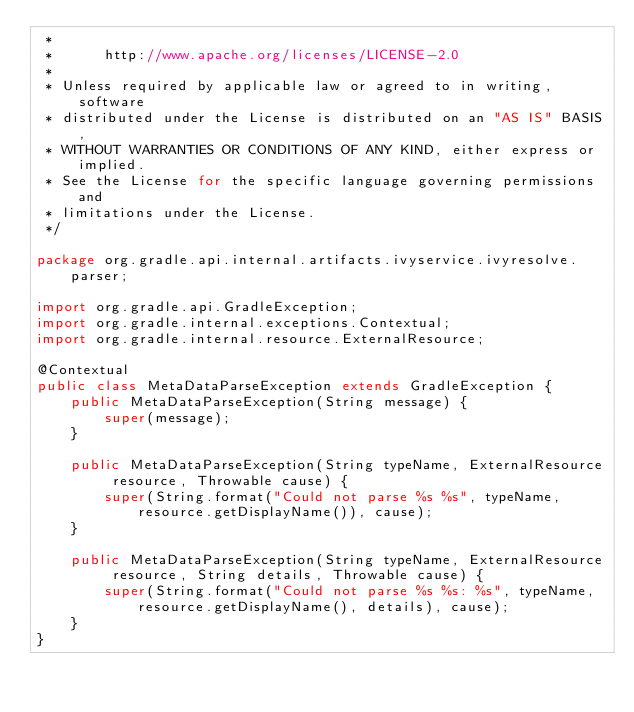<code> <loc_0><loc_0><loc_500><loc_500><_Java_> *
 *      http://www.apache.org/licenses/LICENSE-2.0
 *
 * Unless required by applicable law or agreed to in writing, software
 * distributed under the License is distributed on an "AS IS" BASIS,
 * WITHOUT WARRANTIES OR CONDITIONS OF ANY KIND, either express or implied.
 * See the License for the specific language governing permissions and
 * limitations under the License.
 */

package org.gradle.api.internal.artifacts.ivyservice.ivyresolve.parser;

import org.gradle.api.GradleException;
import org.gradle.internal.exceptions.Contextual;
import org.gradle.internal.resource.ExternalResource;

@Contextual
public class MetaDataParseException extends GradleException {
    public MetaDataParseException(String message) {
        super(message);
    }

    public MetaDataParseException(String typeName, ExternalResource resource, Throwable cause) {
        super(String.format("Could not parse %s %s", typeName, resource.getDisplayName()), cause);
    }

    public MetaDataParseException(String typeName, ExternalResource resource, String details, Throwable cause) {
        super(String.format("Could not parse %s %s: %s", typeName, resource.getDisplayName(), details), cause);
    }
}
</code> 